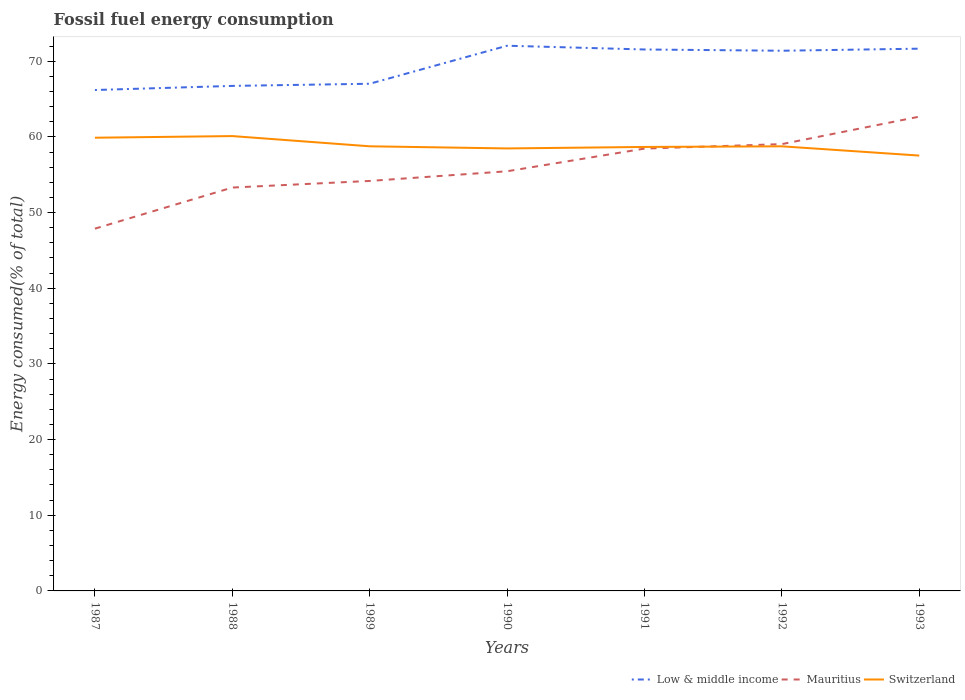Is the number of lines equal to the number of legend labels?
Keep it short and to the point. Yes. Across all years, what is the maximum percentage of energy consumed in Low & middle income?
Your answer should be compact. 66.2. What is the total percentage of energy consumed in Mauritius in the graph?
Your answer should be very brief. -8.5. What is the difference between the highest and the second highest percentage of energy consumed in Low & middle income?
Your answer should be compact. 5.85. Is the percentage of energy consumed in Mauritius strictly greater than the percentage of energy consumed in Low & middle income over the years?
Give a very brief answer. Yes. What is the difference between two consecutive major ticks on the Y-axis?
Your answer should be very brief. 10. Where does the legend appear in the graph?
Your response must be concise. Bottom right. What is the title of the graph?
Your answer should be compact. Fossil fuel energy consumption. Does "Morocco" appear as one of the legend labels in the graph?
Your answer should be very brief. No. What is the label or title of the Y-axis?
Keep it short and to the point. Energy consumed(% of total). What is the Energy consumed(% of total) of Low & middle income in 1987?
Your answer should be very brief. 66.2. What is the Energy consumed(% of total) in Mauritius in 1987?
Offer a very short reply. 47.88. What is the Energy consumed(% of total) of Switzerland in 1987?
Keep it short and to the point. 59.89. What is the Energy consumed(% of total) of Low & middle income in 1988?
Ensure brevity in your answer.  66.74. What is the Energy consumed(% of total) of Mauritius in 1988?
Offer a terse response. 53.31. What is the Energy consumed(% of total) of Switzerland in 1988?
Offer a very short reply. 60.11. What is the Energy consumed(% of total) of Low & middle income in 1989?
Your answer should be very brief. 67.03. What is the Energy consumed(% of total) in Mauritius in 1989?
Provide a short and direct response. 54.18. What is the Energy consumed(% of total) in Switzerland in 1989?
Offer a very short reply. 58.76. What is the Energy consumed(% of total) of Low & middle income in 1990?
Your answer should be very brief. 72.05. What is the Energy consumed(% of total) in Mauritius in 1990?
Give a very brief answer. 55.46. What is the Energy consumed(% of total) of Switzerland in 1990?
Make the answer very short. 58.48. What is the Energy consumed(% of total) in Low & middle income in 1991?
Your answer should be very brief. 71.55. What is the Energy consumed(% of total) of Mauritius in 1991?
Your response must be concise. 58.46. What is the Energy consumed(% of total) of Switzerland in 1991?
Offer a terse response. 58.67. What is the Energy consumed(% of total) of Low & middle income in 1992?
Offer a very short reply. 71.39. What is the Energy consumed(% of total) in Mauritius in 1992?
Provide a succinct answer. 59.05. What is the Energy consumed(% of total) of Switzerland in 1992?
Your response must be concise. 58.76. What is the Energy consumed(% of total) in Low & middle income in 1993?
Provide a short and direct response. 71.66. What is the Energy consumed(% of total) in Mauritius in 1993?
Ensure brevity in your answer.  62.68. What is the Energy consumed(% of total) in Switzerland in 1993?
Provide a short and direct response. 57.53. Across all years, what is the maximum Energy consumed(% of total) of Low & middle income?
Offer a very short reply. 72.05. Across all years, what is the maximum Energy consumed(% of total) in Mauritius?
Your answer should be very brief. 62.68. Across all years, what is the maximum Energy consumed(% of total) of Switzerland?
Make the answer very short. 60.11. Across all years, what is the minimum Energy consumed(% of total) in Low & middle income?
Your answer should be compact. 66.2. Across all years, what is the minimum Energy consumed(% of total) in Mauritius?
Your answer should be very brief. 47.88. Across all years, what is the minimum Energy consumed(% of total) of Switzerland?
Offer a terse response. 57.53. What is the total Energy consumed(% of total) in Low & middle income in the graph?
Offer a very short reply. 486.61. What is the total Energy consumed(% of total) of Mauritius in the graph?
Offer a very short reply. 391.01. What is the total Energy consumed(% of total) in Switzerland in the graph?
Your response must be concise. 412.19. What is the difference between the Energy consumed(% of total) in Low & middle income in 1987 and that in 1988?
Your response must be concise. -0.54. What is the difference between the Energy consumed(% of total) in Mauritius in 1987 and that in 1988?
Offer a very short reply. -5.43. What is the difference between the Energy consumed(% of total) of Switzerland in 1987 and that in 1988?
Your answer should be very brief. -0.22. What is the difference between the Energy consumed(% of total) in Low & middle income in 1987 and that in 1989?
Make the answer very short. -0.83. What is the difference between the Energy consumed(% of total) in Mauritius in 1987 and that in 1989?
Your answer should be very brief. -6.31. What is the difference between the Energy consumed(% of total) in Switzerland in 1987 and that in 1989?
Ensure brevity in your answer.  1.13. What is the difference between the Energy consumed(% of total) in Low & middle income in 1987 and that in 1990?
Keep it short and to the point. -5.85. What is the difference between the Energy consumed(% of total) in Mauritius in 1987 and that in 1990?
Give a very brief answer. -7.58. What is the difference between the Energy consumed(% of total) in Switzerland in 1987 and that in 1990?
Your answer should be very brief. 1.42. What is the difference between the Energy consumed(% of total) in Low & middle income in 1987 and that in 1991?
Your answer should be compact. -5.36. What is the difference between the Energy consumed(% of total) of Mauritius in 1987 and that in 1991?
Your answer should be compact. -10.58. What is the difference between the Energy consumed(% of total) in Switzerland in 1987 and that in 1991?
Offer a very short reply. 1.22. What is the difference between the Energy consumed(% of total) of Low & middle income in 1987 and that in 1992?
Ensure brevity in your answer.  -5.19. What is the difference between the Energy consumed(% of total) in Mauritius in 1987 and that in 1992?
Keep it short and to the point. -11.17. What is the difference between the Energy consumed(% of total) in Switzerland in 1987 and that in 1992?
Offer a terse response. 1.14. What is the difference between the Energy consumed(% of total) in Low & middle income in 1987 and that in 1993?
Keep it short and to the point. -5.46. What is the difference between the Energy consumed(% of total) in Mauritius in 1987 and that in 1993?
Your answer should be compact. -14.8. What is the difference between the Energy consumed(% of total) in Switzerland in 1987 and that in 1993?
Your answer should be compact. 2.36. What is the difference between the Energy consumed(% of total) of Low & middle income in 1988 and that in 1989?
Offer a terse response. -0.29. What is the difference between the Energy consumed(% of total) of Mauritius in 1988 and that in 1989?
Make the answer very short. -0.87. What is the difference between the Energy consumed(% of total) in Switzerland in 1988 and that in 1989?
Provide a short and direct response. 1.35. What is the difference between the Energy consumed(% of total) in Low & middle income in 1988 and that in 1990?
Provide a short and direct response. -5.31. What is the difference between the Energy consumed(% of total) of Mauritius in 1988 and that in 1990?
Ensure brevity in your answer.  -2.15. What is the difference between the Energy consumed(% of total) of Switzerland in 1988 and that in 1990?
Make the answer very short. 1.63. What is the difference between the Energy consumed(% of total) of Low & middle income in 1988 and that in 1991?
Give a very brief answer. -4.81. What is the difference between the Energy consumed(% of total) in Mauritius in 1988 and that in 1991?
Provide a short and direct response. -5.15. What is the difference between the Energy consumed(% of total) of Switzerland in 1988 and that in 1991?
Your answer should be compact. 1.44. What is the difference between the Energy consumed(% of total) of Low & middle income in 1988 and that in 1992?
Make the answer very short. -4.65. What is the difference between the Energy consumed(% of total) of Mauritius in 1988 and that in 1992?
Provide a succinct answer. -5.74. What is the difference between the Energy consumed(% of total) in Switzerland in 1988 and that in 1992?
Provide a short and direct response. 1.35. What is the difference between the Energy consumed(% of total) of Low & middle income in 1988 and that in 1993?
Offer a terse response. -4.92. What is the difference between the Energy consumed(% of total) of Mauritius in 1988 and that in 1993?
Your response must be concise. -9.37. What is the difference between the Energy consumed(% of total) of Switzerland in 1988 and that in 1993?
Provide a short and direct response. 2.58. What is the difference between the Energy consumed(% of total) of Low & middle income in 1989 and that in 1990?
Offer a terse response. -5.02. What is the difference between the Energy consumed(% of total) of Mauritius in 1989 and that in 1990?
Provide a short and direct response. -1.28. What is the difference between the Energy consumed(% of total) of Switzerland in 1989 and that in 1990?
Offer a terse response. 0.28. What is the difference between the Energy consumed(% of total) in Low & middle income in 1989 and that in 1991?
Your answer should be very brief. -4.53. What is the difference between the Energy consumed(% of total) of Mauritius in 1989 and that in 1991?
Your answer should be compact. -4.27. What is the difference between the Energy consumed(% of total) in Switzerland in 1989 and that in 1991?
Provide a succinct answer. 0.09. What is the difference between the Energy consumed(% of total) in Low & middle income in 1989 and that in 1992?
Provide a succinct answer. -4.36. What is the difference between the Energy consumed(% of total) of Mauritius in 1989 and that in 1992?
Your answer should be compact. -4.87. What is the difference between the Energy consumed(% of total) of Switzerland in 1989 and that in 1992?
Give a very brief answer. 0. What is the difference between the Energy consumed(% of total) in Low & middle income in 1989 and that in 1993?
Provide a short and direct response. -4.63. What is the difference between the Energy consumed(% of total) of Mauritius in 1989 and that in 1993?
Make the answer very short. -8.5. What is the difference between the Energy consumed(% of total) in Switzerland in 1989 and that in 1993?
Provide a short and direct response. 1.23. What is the difference between the Energy consumed(% of total) of Low & middle income in 1990 and that in 1991?
Make the answer very short. 0.5. What is the difference between the Energy consumed(% of total) in Mauritius in 1990 and that in 1991?
Your answer should be compact. -3. What is the difference between the Energy consumed(% of total) in Switzerland in 1990 and that in 1991?
Give a very brief answer. -0.2. What is the difference between the Energy consumed(% of total) of Low & middle income in 1990 and that in 1992?
Your answer should be very brief. 0.66. What is the difference between the Energy consumed(% of total) of Mauritius in 1990 and that in 1992?
Your answer should be compact. -3.59. What is the difference between the Energy consumed(% of total) of Switzerland in 1990 and that in 1992?
Give a very brief answer. -0.28. What is the difference between the Energy consumed(% of total) in Low & middle income in 1990 and that in 1993?
Provide a succinct answer. 0.39. What is the difference between the Energy consumed(% of total) of Mauritius in 1990 and that in 1993?
Provide a short and direct response. -7.22. What is the difference between the Energy consumed(% of total) of Switzerland in 1990 and that in 1993?
Keep it short and to the point. 0.94. What is the difference between the Energy consumed(% of total) in Low & middle income in 1991 and that in 1992?
Provide a short and direct response. 0.16. What is the difference between the Energy consumed(% of total) in Mauritius in 1991 and that in 1992?
Your answer should be very brief. -0.59. What is the difference between the Energy consumed(% of total) in Switzerland in 1991 and that in 1992?
Offer a very short reply. -0.08. What is the difference between the Energy consumed(% of total) in Low & middle income in 1991 and that in 1993?
Keep it short and to the point. -0.11. What is the difference between the Energy consumed(% of total) of Mauritius in 1991 and that in 1993?
Ensure brevity in your answer.  -4.22. What is the difference between the Energy consumed(% of total) in Switzerland in 1991 and that in 1993?
Provide a succinct answer. 1.14. What is the difference between the Energy consumed(% of total) of Low & middle income in 1992 and that in 1993?
Offer a terse response. -0.27. What is the difference between the Energy consumed(% of total) in Mauritius in 1992 and that in 1993?
Make the answer very short. -3.63. What is the difference between the Energy consumed(% of total) of Switzerland in 1992 and that in 1993?
Give a very brief answer. 1.22. What is the difference between the Energy consumed(% of total) in Low & middle income in 1987 and the Energy consumed(% of total) in Mauritius in 1988?
Ensure brevity in your answer.  12.89. What is the difference between the Energy consumed(% of total) of Low & middle income in 1987 and the Energy consumed(% of total) of Switzerland in 1988?
Your answer should be compact. 6.09. What is the difference between the Energy consumed(% of total) of Mauritius in 1987 and the Energy consumed(% of total) of Switzerland in 1988?
Your answer should be compact. -12.23. What is the difference between the Energy consumed(% of total) of Low & middle income in 1987 and the Energy consumed(% of total) of Mauritius in 1989?
Your answer should be very brief. 12.02. What is the difference between the Energy consumed(% of total) in Low & middle income in 1987 and the Energy consumed(% of total) in Switzerland in 1989?
Your response must be concise. 7.44. What is the difference between the Energy consumed(% of total) in Mauritius in 1987 and the Energy consumed(% of total) in Switzerland in 1989?
Offer a terse response. -10.88. What is the difference between the Energy consumed(% of total) in Low & middle income in 1987 and the Energy consumed(% of total) in Mauritius in 1990?
Provide a short and direct response. 10.74. What is the difference between the Energy consumed(% of total) of Low & middle income in 1987 and the Energy consumed(% of total) of Switzerland in 1990?
Keep it short and to the point. 7.72. What is the difference between the Energy consumed(% of total) of Mauritius in 1987 and the Energy consumed(% of total) of Switzerland in 1990?
Your response must be concise. -10.6. What is the difference between the Energy consumed(% of total) in Low & middle income in 1987 and the Energy consumed(% of total) in Mauritius in 1991?
Give a very brief answer. 7.74. What is the difference between the Energy consumed(% of total) of Low & middle income in 1987 and the Energy consumed(% of total) of Switzerland in 1991?
Keep it short and to the point. 7.53. What is the difference between the Energy consumed(% of total) in Mauritius in 1987 and the Energy consumed(% of total) in Switzerland in 1991?
Provide a short and direct response. -10.8. What is the difference between the Energy consumed(% of total) in Low & middle income in 1987 and the Energy consumed(% of total) in Mauritius in 1992?
Provide a succinct answer. 7.15. What is the difference between the Energy consumed(% of total) in Low & middle income in 1987 and the Energy consumed(% of total) in Switzerland in 1992?
Give a very brief answer. 7.44. What is the difference between the Energy consumed(% of total) in Mauritius in 1987 and the Energy consumed(% of total) in Switzerland in 1992?
Keep it short and to the point. -10.88. What is the difference between the Energy consumed(% of total) in Low & middle income in 1987 and the Energy consumed(% of total) in Mauritius in 1993?
Keep it short and to the point. 3.52. What is the difference between the Energy consumed(% of total) of Low & middle income in 1987 and the Energy consumed(% of total) of Switzerland in 1993?
Your response must be concise. 8.67. What is the difference between the Energy consumed(% of total) in Mauritius in 1987 and the Energy consumed(% of total) in Switzerland in 1993?
Give a very brief answer. -9.66. What is the difference between the Energy consumed(% of total) in Low & middle income in 1988 and the Energy consumed(% of total) in Mauritius in 1989?
Provide a short and direct response. 12.56. What is the difference between the Energy consumed(% of total) of Low & middle income in 1988 and the Energy consumed(% of total) of Switzerland in 1989?
Offer a terse response. 7.98. What is the difference between the Energy consumed(% of total) of Mauritius in 1988 and the Energy consumed(% of total) of Switzerland in 1989?
Give a very brief answer. -5.45. What is the difference between the Energy consumed(% of total) in Low & middle income in 1988 and the Energy consumed(% of total) in Mauritius in 1990?
Offer a very short reply. 11.28. What is the difference between the Energy consumed(% of total) of Low & middle income in 1988 and the Energy consumed(% of total) of Switzerland in 1990?
Offer a very short reply. 8.26. What is the difference between the Energy consumed(% of total) in Mauritius in 1988 and the Energy consumed(% of total) in Switzerland in 1990?
Provide a succinct answer. -5.17. What is the difference between the Energy consumed(% of total) in Low & middle income in 1988 and the Energy consumed(% of total) in Mauritius in 1991?
Keep it short and to the point. 8.28. What is the difference between the Energy consumed(% of total) in Low & middle income in 1988 and the Energy consumed(% of total) in Switzerland in 1991?
Your response must be concise. 8.07. What is the difference between the Energy consumed(% of total) of Mauritius in 1988 and the Energy consumed(% of total) of Switzerland in 1991?
Your answer should be compact. -5.36. What is the difference between the Energy consumed(% of total) in Low & middle income in 1988 and the Energy consumed(% of total) in Mauritius in 1992?
Ensure brevity in your answer.  7.69. What is the difference between the Energy consumed(% of total) in Low & middle income in 1988 and the Energy consumed(% of total) in Switzerland in 1992?
Your response must be concise. 7.98. What is the difference between the Energy consumed(% of total) of Mauritius in 1988 and the Energy consumed(% of total) of Switzerland in 1992?
Your response must be concise. -5.45. What is the difference between the Energy consumed(% of total) in Low & middle income in 1988 and the Energy consumed(% of total) in Mauritius in 1993?
Keep it short and to the point. 4.06. What is the difference between the Energy consumed(% of total) in Low & middle income in 1988 and the Energy consumed(% of total) in Switzerland in 1993?
Offer a very short reply. 9.21. What is the difference between the Energy consumed(% of total) of Mauritius in 1988 and the Energy consumed(% of total) of Switzerland in 1993?
Provide a succinct answer. -4.22. What is the difference between the Energy consumed(% of total) in Low & middle income in 1989 and the Energy consumed(% of total) in Mauritius in 1990?
Keep it short and to the point. 11.57. What is the difference between the Energy consumed(% of total) of Low & middle income in 1989 and the Energy consumed(% of total) of Switzerland in 1990?
Ensure brevity in your answer.  8.55. What is the difference between the Energy consumed(% of total) in Mauritius in 1989 and the Energy consumed(% of total) in Switzerland in 1990?
Your response must be concise. -4.29. What is the difference between the Energy consumed(% of total) in Low & middle income in 1989 and the Energy consumed(% of total) in Mauritius in 1991?
Provide a succinct answer. 8.57. What is the difference between the Energy consumed(% of total) in Low & middle income in 1989 and the Energy consumed(% of total) in Switzerland in 1991?
Ensure brevity in your answer.  8.35. What is the difference between the Energy consumed(% of total) of Mauritius in 1989 and the Energy consumed(% of total) of Switzerland in 1991?
Offer a very short reply. -4.49. What is the difference between the Energy consumed(% of total) of Low & middle income in 1989 and the Energy consumed(% of total) of Mauritius in 1992?
Offer a very short reply. 7.98. What is the difference between the Energy consumed(% of total) in Low & middle income in 1989 and the Energy consumed(% of total) in Switzerland in 1992?
Keep it short and to the point. 8.27. What is the difference between the Energy consumed(% of total) in Mauritius in 1989 and the Energy consumed(% of total) in Switzerland in 1992?
Give a very brief answer. -4.57. What is the difference between the Energy consumed(% of total) in Low & middle income in 1989 and the Energy consumed(% of total) in Mauritius in 1993?
Make the answer very short. 4.35. What is the difference between the Energy consumed(% of total) of Low & middle income in 1989 and the Energy consumed(% of total) of Switzerland in 1993?
Your answer should be very brief. 9.49. What is the difference between the Energy consumed(% of total) in Mauritius in 1989 and the Energy consumed(% of total) in Switzerland in 1993?
Your answer should be very brief. -3.35. What is the difference between the Energy consumed(% of total) in Low & middle income in 1990 and the Energy consumed(% of total) in Mauritius in 1991?
Offer a terse response. 13.59. What is the difference between the Energy consumed(% of total) in Low & middle income in 1990 and the Energy consumed(% of total) in Switzerland in 1991?
Your answer should be compact. 13.38. What is the difference between the Energy consumed(% of total) of Mauritius in 1990 and the Energy consumed(% of total) of Switzerland in 1991?
Provide a short and direct response. -3.21. What is the difference between the Energy consumed(% of total) of Low & middle income in 1990 and the Energy consumed(% of total) of Mauritius in 1992?
Provide a succinct answer. 13. What is the difference between the Energy consumed(% of total) of Low & middle income in 1990 and the Energy consumed(% of total) of Switzerland in 1992?
Provide a succinct answer. 13.29. What is the difference between the Energy consumed(% of total) of Mauritius in 1990 and the Energy consumed(% of total) of Switzerland in 1992?
Keep it short and to the point. -3.3. What is the difference between the Energy consumed(% of total) in Low & middle income in 1990 and the Energy consumed(% of total) in Mauritius in 1993?
Ensure brevity in your answer.  9.37. What is the difference between the Energy consumed(% of total) in Low & middle income in 1990 and the Energy consumed(% of total) in Switzerland in 1993?
Your response must be concise. 14.52. What is the difference between the Energy consumed(% of total) of Mauritius in 1990 and the Energy consumed(% of total) of Switzerland in 1993?
Your answer should be very brief. -2.07. What is the difference between the Energy consumed(% of total) in Low & middle income in 1991 and the Energy consumed(% of total) in Mauritius in 1992?
Make the answer very short. 12.5. What is the difference between the Energy consumed(% of total) of Low & middle income in 1991 and the Energy consumed(% of total) of Switzerland in 1992?
Your answer should be very brief. 12.8. What is the difference between the Energy consumed(% of total) of Mauritius in 1991 and the Energy consumed(% of total) of Switzerland in 1992?
Your answer should be very brief. -0.3. What is the difference between the Energy consumed(% of total) of Low & middle income in 1991 and the Energy consumed(% of total) of Mauritius in 1993?
Provide a short and direct response. 8.87. What is the difference between the Energy consumed(% of total) of Low & middle income in 1991 and the Energy consumed(% of total) of Switzerland in 1993?
Offer a terse response. 14.02. What is the difference between the Energy consumed(% of total) in Mauritius in 1991 and the Energy consumed(% of total) in Switzerland in 1993?
Make the answer very short. 0.92. What is the difference between the Energy consumed(% of total) of Low & middle income in 1992 and the Energy consumed(% of total) of Mauritius in 1993?
Your response must be concise. 8.71. What is the difference between the Energy consumed(% of total) of Low & middle income in 1992 and the Energy consumed(% of total) of Switzerland in 1993?
Ensure brevity in your answer.  13.86. What is the difference between the Energy consumed(% of total) of Mauritius in 1992 and the Energy consumed(% of total) of Switzerland in 1993?
Provide a succinct answer. 1.52. What is the average Energy consumed(% of total) in Low & middle income per year?
Your answer should be compact. 69.52. What is the average Energy consumed(% of total) of Mauritius per year?
Give a very brief answer. 55.86. What is the average Energy consumed(% of total) of Switzerland per year?
Offer a terse response. 58.88. In the year 1987, what is the difference between the Energy consumed(% of total) of Low & middle income and Energy consumed(% of total) of Mauritius?
Keep it short and to the point. 18.32. In the year 1987, what is the difference between the Energy consumed(% of total) of Low & middle income and Energy consumed(% of total) of Switzerland?
Give a very brief answer. 6.3. In the year 1987, what is the difference between the Energy consumed(% of total) in Mauritius and Energy consumed(% of total) in Switzerland?
Provide a short and direct response. -12.02. In the year 1988, what is the difference between the Energy consumed(% of total) of Low & middle income and Energy consumed(% of total) of Mauritius?
Your answer should be very brief. 13.43. In the year 1988, what is the difference between the Energy consumed(% of total) of Low & middle income and Energy consumed(% of total) of Switzerland?
Provide a short and direct response. 6.63. In the year 1988, what is the difference between the Energy consumed(% of total) of Mauritius and Energy consumed(% of total) of Switzerland?
Ensure brevity in your answer.  -6.8. In the year 1989, what is the difference between the Energy consumed(% of total) in Low & middle income and Energy consumed(% of total) in Mauritius?
Offer a very short reply. 12.84. In the year 1989, what is the difference between the Energy consumed(% of total) of Low & middle income and Energy consumed(% of total) of Switzerland?
Ensure brevity in your answer.  8.27. In the year 1989, what is the difference between the Energy consumed(% of total) of Mauritius and Energy consumed(% of total) of Switzerland?
Make the answer very short. -4.58. In the year 1990, what is the difference between the Energy consumed(% of total) in Low & middle income and Energy consumed(% of total) in Mauritius?
Ensure brevity in your answer.  16.59. In the year 1990, what is the difference between the Energy consumed(% of total) in Low & middle income and Energy consumed(% of total) in Switzerland?
Ensure brevity in your answer.  13.57. In the year 1990, what is the difference between the Energy consumed(% of total) in Mauritius and Energy consumed(% of total) in Switzerland?
Your answer should be very brief. -3.02. In the year 1991, what is the difference between the Energy consumed(% of total) in Low & middle income and Energy consumed(% of total) in Mauritius?
Give a very brief answer. 13.1. In the year 1991, what is the difference between the Energy consumed(% of total) in Low & middle income and Energy consumed(% of total) in Switzerland?
Your answer should be compact. 12.88. In the year 1991, what is the difference between the Energy consumed(% of total) of Mauritius and Energy consumed(% of total) of Switzerland?
Offer a very short reply. -0.22. In the year 1992, what is the difference between the Energy consumed(% of total) of Low & middle income and Energy consumed(% of total) of Mauritius?
Make the answer very short. 12.34. In the year 1992, what is the difference between the Energy consumed(% of total) in Low & middle income and Energy consumed(% of total) in Switzerland?
Offer a very short reply. 12.63. In the year 1992, what is the difference between the Energy consumed(% of total) in Mauritius and Energy consumed(% of total) in Switzerland?
Provide a succinct answer. 0.29. In the year 1993, what is the difference between the Energy consumed(% of total) of Low & middle income and Energy consumed(% of total) of Mauritius?
Offer a terse response. 8.98. In the year 1993, what is the difference between the Energy consumed(% of total) in Low & middle income and Energy consumed(% of total) in Switzerland?
Keep it short and to the point. 14.13. In the year 1993, what is the difference between the Energy consumed(% of total) of Mauritius and Energy consumed(% of total) of Switzerland?
Provide a succinct answer. 5.15. What is the ratio of the Energy consumed(% of total) in Mauritius in 1987 to that in 1988?
Make the answer very short. 0.9. What is the ratio of the Energy consumed(% of total) of Switzerland in 1987 to that in 1988?
Offer a terse response. 1. What is the ratio of the Energy consumed(% of total) of Low & middle income in 1987 to that in 1989?
Provide a short and direct response. 0.99. What is the ratio of the Energy consumed(% of total) of Mauritius in 1987 to that in 1989?
Offer a very short reply. 0.88. What is the ratio of the Energy consumed(% of total) in Switzerland in 1987 to that in 1989?
Your answer should be compact. 1.02. What is the ratio of the Energy consumed(% of total) in Low & middle income in 1987 to that in 1990?
Offer a terse response. 0.92. What is the ratio of the Energy consumed(% of total) in Mauritius in 1987 to that in 1990?
Offer a very short reply. 0.86. What is the ratio of the Energy consumed(% of total) in Switzerland in 1987 to that in 1990?
Ensure brevity in your answer.  1.02. What is the ratio of the Energy consumed(% of total) of Low & middle income in 1987 to that in 1991?
Provide a short and direct response. 0.93. What is the ratio of the Energy consumed(% of total) of Mauritius in 1987 to that in 1991?
Offer a very short reply. 0.82. What is the ratio of the Energy consumed(% of total) in Switzerland in 1987 to that in 1991?
Make the answer very short. 1.02. What is the ratio of the Energy consumed(% of total) of Low & middle income in 1987 to that in 1992?
Your answer should be very brief. 0.93. What is the ratio of the Energy consumed(% of total) of Mauritius in 1987 to that in 1992?
Offer a terse response. 0.81. What is the ratio of the Energy consumed(% of total) of Switzerland in 1987 to that in 1992?
Provide a short and direct response. 1.02. What is the ratio of the Energy consumed(% of total) of Low & middle income in 1987 to that in 1993?
Make the answer very short. 0.92. What is the ratio of the Energy consumed(% of total) of Mauritius in 1987 to that in 1993?
Make the answer very short. 0.76. What is the ratio of the Energy consumed(% of total) in Switzerland in 1987 to that in 1993?
Keep it short and to the point. 1.04. What is the ratio of the Energy consumed(% of total) of Mauritius in 1988 to that in 1989?
Offer a very short reply. 0.98. What is the ratio of the Energy consumed(% of total) of Low & middle income in 1988 to that in 1990?
Provide a short and direct response. 0.93. What is the ratio of the Energy consumed(% of total) of Mauritius in 1988 to that in 1990?
Give a very brief answer. 0.96. What is the ratio of the Energy consumed(% of total) in Switzerland in 1988 to that in 1990?
Your response must be concise. 1.03. What is the ratio of the Energy consumed(% of total) of Low & middle income in 1988 to that in 1991?
Offer a very short reply. 0.93. What is the ratio of the Energy consumed(% of total) of Mauritius in 1988 to that in 1991?
Provide a succinct answer. 0.91. What is the ratio of the Energy consumed(% of total) in Switzerland in 1988 to that in 1991?
Your answer should be very brief. 1.02. What is the ratio of the Energy consumed(% of total) of Low & middle income in 1988 to that in 1992?
Give a very brief answer. 0.93. What is the ratio of the Energy consumed(% of total) in Mauritius in 1988 to that in 1992?
Offer a terse response. 0.9. What is the ratio of the Energy consumed(% of total) in Low & middle income in 1988 to that in 1993?
Make the answer very short. 0.93. What is the ratio of the Energy consumed(% of total) of Mauritius in 1988 to that in 1993?
Provide a succinct answer. 0.85. What is the ratio of the Energy consumed(% of total) in Switzerland in 1988 to that in 1993?
Offer a terse response. 1.04. What is the ratio of the Energy consumed(% of total) in Low & middle income in 1989 to that in 1990?
Your answer should be compact. 0.93. What is the ratio of the Energy consumed(% of total) of Low & middle income in 1989 to that in 1991?
Make the answer very short. 0.94. What is the ratio of the Energy consumed(% of total) in Mauritius in 1989 to that in 1991?
Provide a short and direct response. 0.93. What is the ratio of the Energy consumed(% of total) of Low & middle income in 1989 to that in 1992?
Ensure brevity in your answer.  0.94. What is the ratio of the Energy consumed(% of total) in Mauritius in 1989 to that in 1992?
Make the answer very short. 0.92. What is the ratio of the Energy consumed(% of total) of Low & middle income in 1989 to that in 1993?
Make the answer very short. 0.94. What is the ratio of the Energy consumed(% of total) in Mauritius in 1989 to that in 1993?
Offer a terse response. 0.86. What is the ratio of the Energy consumed(% of total) in Switzerland in 1989 to that in 1993?
Offer a very short reply. 1.02. What is the ratio of the Energy consumed(% of total) in Low & middle income in 1990 to that in 1991?
Keep it short and to the point. 1.01. What is the ratio of the Energy consumed(% of total) in Mauritius in 1990 to that in 1991?
Make the answer very short. 0.95. What is the ratio of the Energy consumed(% of total) in Switzerland in 1990 to that in 1991?
Your response must be concise. 1. What is the ratio of the Energy consumed(% of total) of Low & middle income in 1990 to that in 1992?
Provide a succinct answer. 1.01. What is the ratio of the Energy consumed(% of total) in Mauritius in 1990 to that in 1992?
Keep it short and to the point. 0.94. What is the ratio of the Energy consumed(% of total) in Switzerland in 1990 to that in 1992?
Keep it short and to the point. 1. What is the ratio of the Energy consumed(% of total) in Low & middle income in 1990 to that in 1993?
Offer a terse response. 1.01. What is the ratio of the Energy consumed(% of total) in Mauritius in 1990 to that in 1993?
Your answer should be compact. 0.88. What is the ratio of the Energy consumed(% of total) of Switzerland in 1990 to that in 1993?
Provide a short and direct response. 1.02. What is the ratio of the Energy consumed(% of total) in Mauritius in 1991 to that in 1993?
Offer a terse response. 0.93. What is the ratio of the Energy consumed(% of total) in Switzerland in 1991 to that in 1993?
Provide a succinct answer. 1.02. What is the ratio of the Energy consumed(% of total) of Mauritius in 1992 to that in 1993?
Offer a terse response. 0.94. What is the ratio of the Energy consumed(% of total) in Switzerland in 1992 to that in 1993?
Offer a very short reply. 1.02. What is the difference between the highest and the second highest Energy consumed(% of total) of Low & middle income?
Provide a short and direct response. 0.39. What is the difference between the highest and the second highest Energy consumed(% of total) of Mauritius?
Keep it short and to the point. 3.63. What is the difference between the highest and the second highest Energy consumed(% of total) in Switzerland?
Provide a short and direct response. 0.22. What is the difference between the highest and the lowest Energy consumed(% of total) in Low & middle income?
Your answer should be very brief. 5.85. What is the difference between the highest and the lowest Energy consumed(% of total) in Mauritius?
Offer a very short reply. 14.8. What is the difference between the highest and the lowest Energy consumed(% of total) of Switzerland?
Provide a short and direct response. 2.58. 